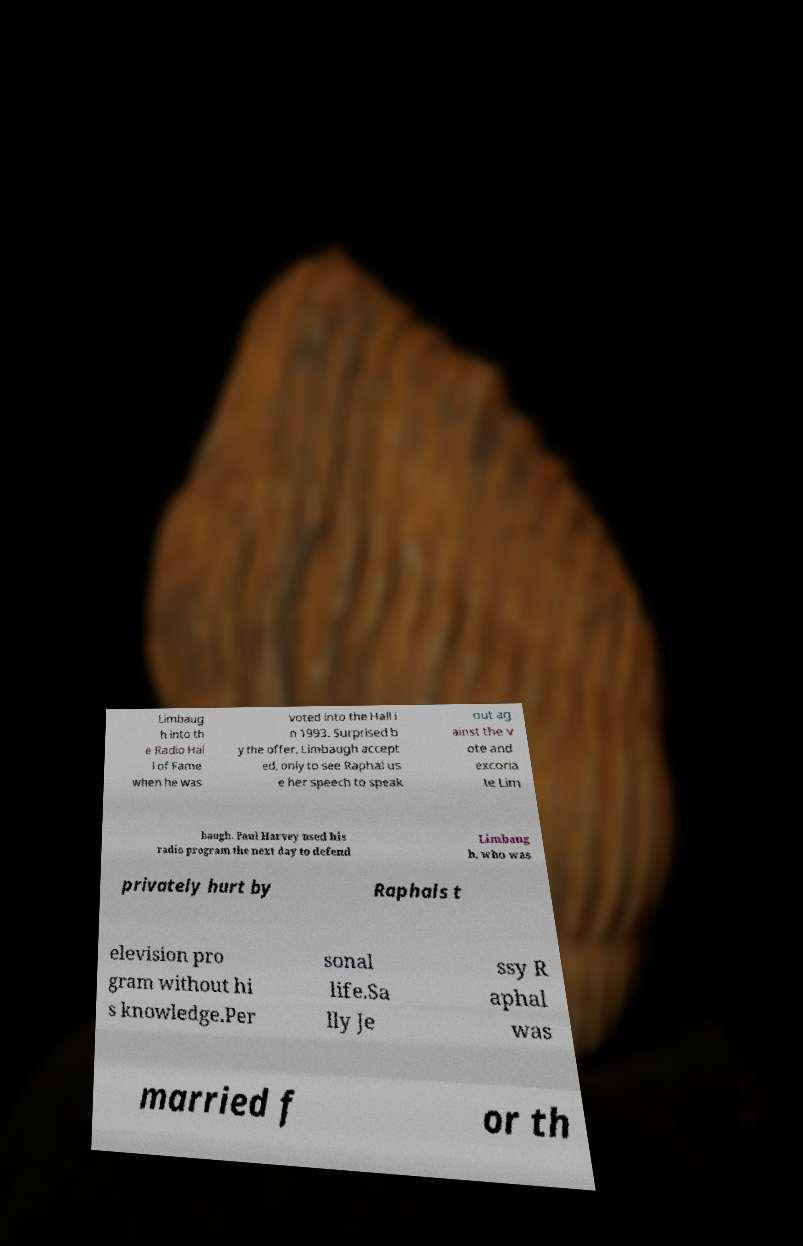For documentation purposes, I need the text within this image transcribed. Could you provide that? Limbaug h into th e Radio Hal l of Fame when he was voted into the Hall i n 1993. Surprised b y the offer, Limbaugh accept ed, only to see Raphal us e her speech to speak out ag ainst the v ote and excoria te Lim baugh. Paul Harvey used his radio program the next day to defend Limbaug h, who was privately hurt by Raphals t elevision pro gram without hi s knowledge.Per sonal life.Sa lly Je ssy R aphal was married f or th 